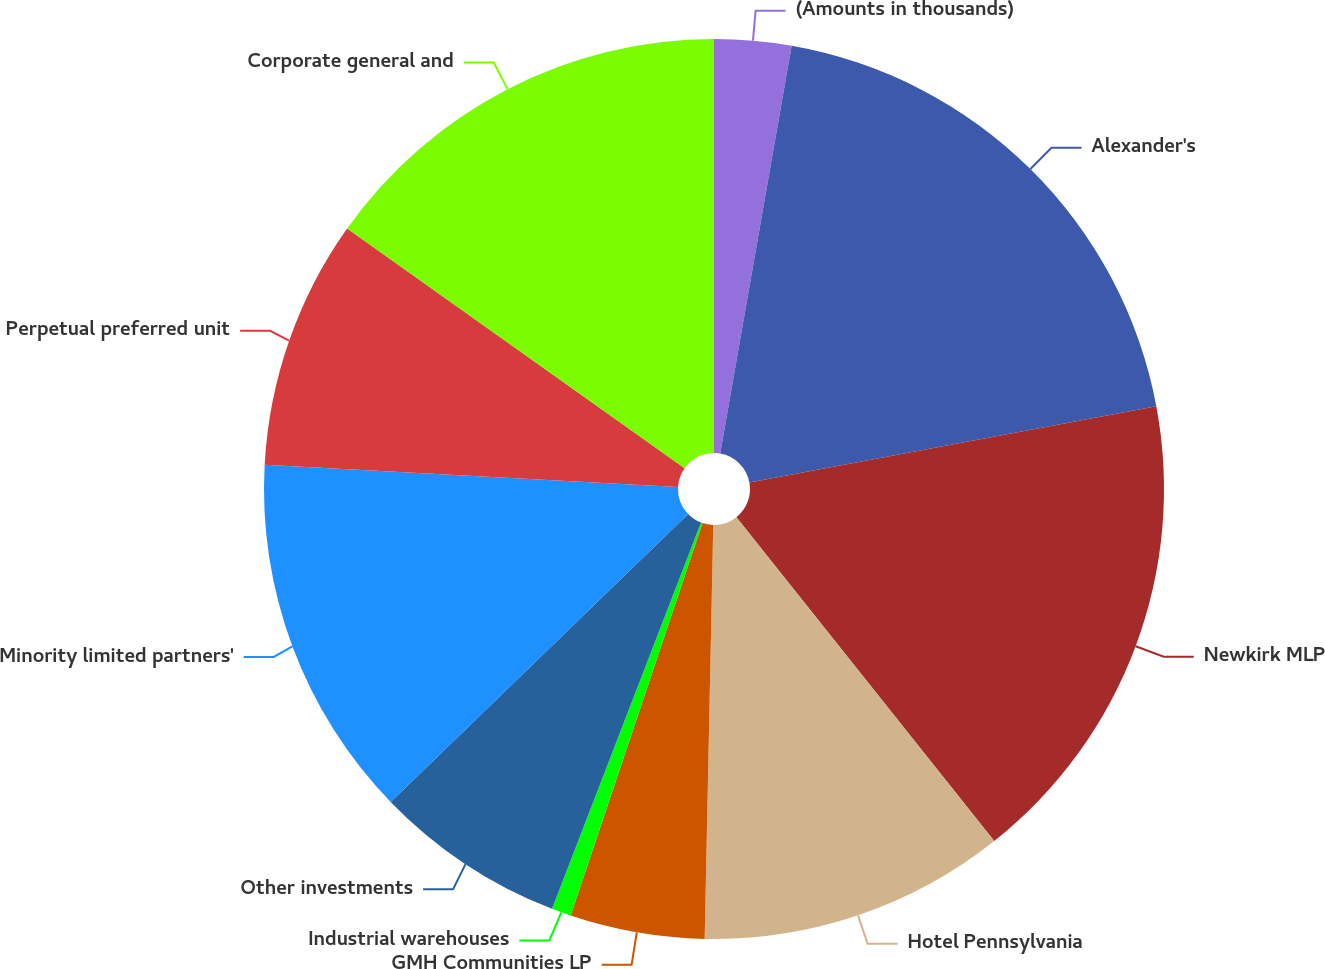Convert chart. <chart><loc_0><loc_0><loc_500><loc_500><pie_chart><fcel>(Amounts in thousands)<fcel>Alexander's<fcel>Newkirk MLP<fcel>Hotel Pennsylvania<fcel>GMH Communities LP<fcel>Industrial warehouses<fcel>Other investments<fcel>Minority limited partners'<fcel>Perpetual preferred unit<fcel>Corporate general and<nl><fcel>2.76%<fcel>19.3%<fcel>17.24%<fcel>11.03%<fcel>4.83%<fcel>0.7%<fcel>6.9%<fcel>13.1%<fcel>8.97%<fcel>15.17%<nl></chart> 